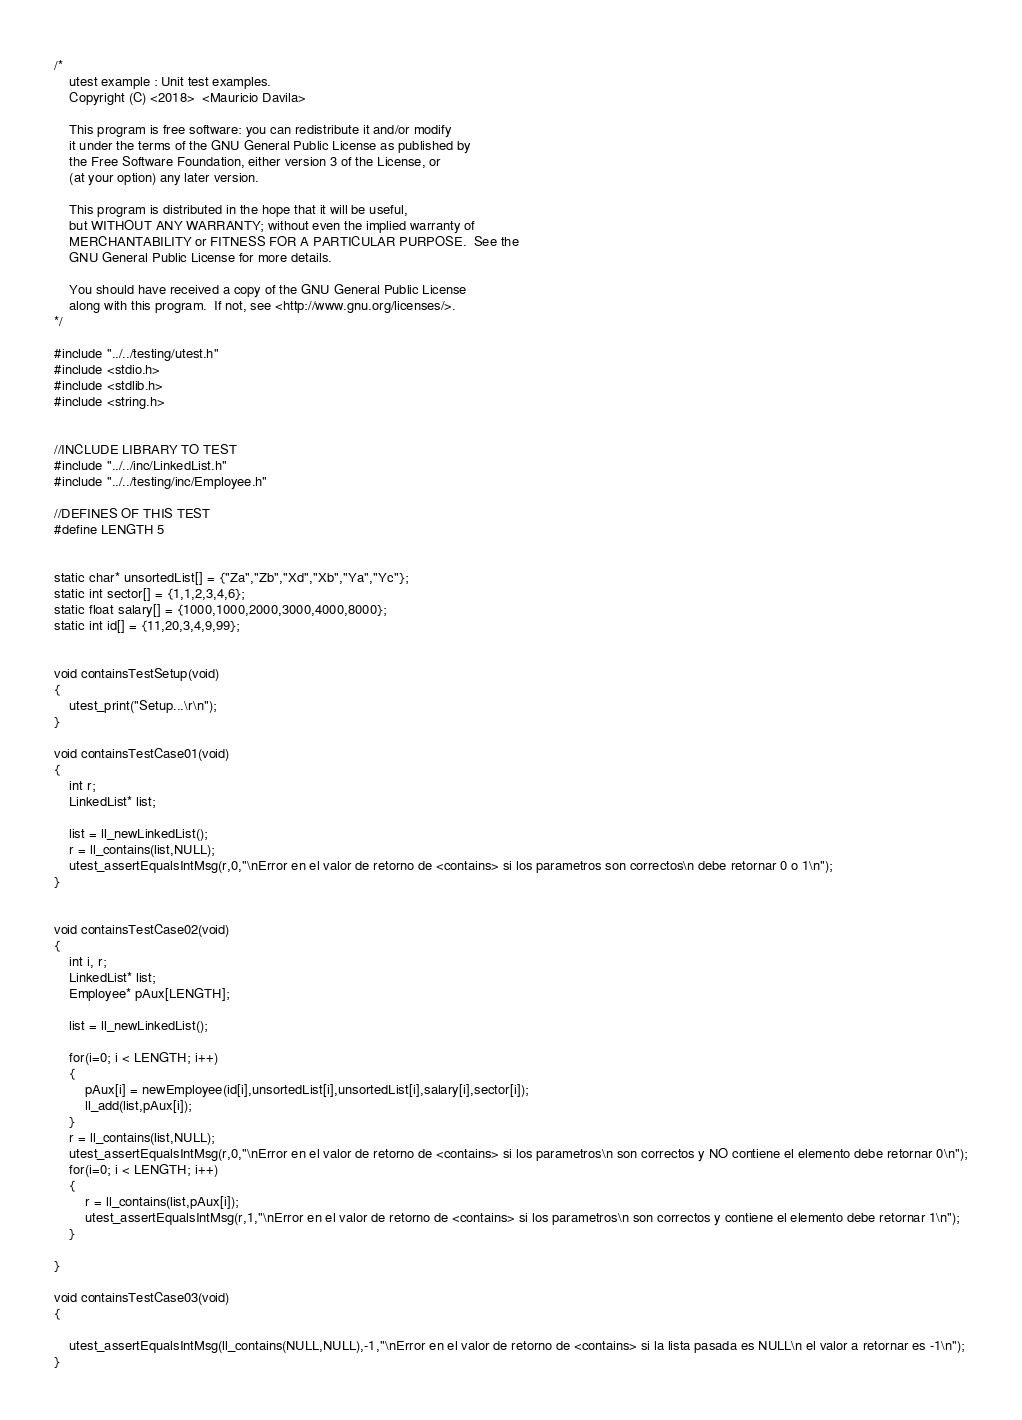<code> <loc_0><loc_0><loc_500><loc_500><_C_>/*
    utest example : Unit test examples.
    Copyright (C) <2018>  <Mauricio Davila>

    This program is free software: you can redistribute it and/or modify
    it under the terms of the GNU General Public License as published by
    the Free Software Foundation, either version 3 of the License, or
    (at your option) any later version.

    This program is distributed in the hope that it will be useful,
    but WITHOUT ANY WARRANTY; without even the implied warranty of
    MERCHANTABILITY or FITNESS FOR A PARTICULAR PURPOSE.  See the
    GNU General Public License for more details.

    You should have received a copy of the GNU General Public License
    along with this program.  If not, see <http://www.gnu.org/licenses/>.
*/

#include "../../testing/utest.h"
#include <stdio.h>
#include <stdlib.h>
#include <string.h>


//INCLUDE LIBRARY TO TEST
#include "../../inc/LinkedList.h"
#include "../../testing/inc/Employee.h"

//DEFINES OF THIS TEST
#define LENGTH 5


static char* unsortedList[] = {"Za","Zb","Xd","Xb","Ya","Yc"};
static int sector[] = {1,1,2,3,4,6};
static float salary[] = {1000,1000,2000,3000,4000,8000};
static int id[] = {11,20,3,4,9,99};


void containsTestSetup(void)
{
	utest_print("Setup...\r\n");
}

void containsTestCase01(void)
{
    int r;
    LinkedList* list;

    list = ll_newLinkedList();
    r = ll_contains(list,NULL);
    utest_assertEqualsIntMsg(r,0,"\nError en el valor de retorno de <contains> si los parametros son correctos\n debe retornar 0 o 1\n");
}


void containsTestCase02(void)
{
    int i, r;
    LinkedList* list;
    Employee* pAux[LENGTH];

    list = ll_newLinkedList();

    for(i=0; i < LENGTH; i++)
    {
        pAux[i] = newEmployee(id[i],unsortedList[i],unsortedList[i],salary[i],sector[i]);
        ll_add(list,pAux[i]);
    }
    r = ll_contains(list,NULL);
    utest_assertEqualsIntMsg(r,0,"\nError en el valor de retorno de <contains> si los parametros\n son correctos y NO contiene el elemento debe retornar 0\n");
    for(i=0; i < LENGTH; i++)
    {
        r = ll_contains(list,pAux[i]);
        utest_assertEqualsIntMsg(r,1,"\nError en el valor de retorno de <contains> si los parametros\n son correctos y contiene el elemento debe retornar 1\n");
    }

}

void containsTestCase03(void)
{

    utest_assertEqualsIntMsg(ll_contains(NULL,NULL),-1,"\nError en el valor de retorno de <contains> si la lista pasada es NULL\n el valor a retornar es -1\n");
}


</code> 